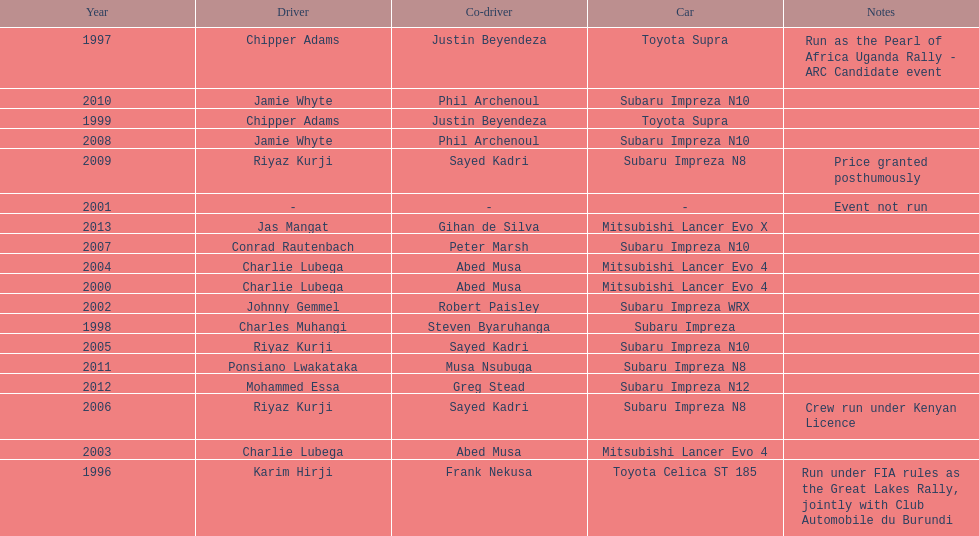How many drivers won at least twice? 4. 